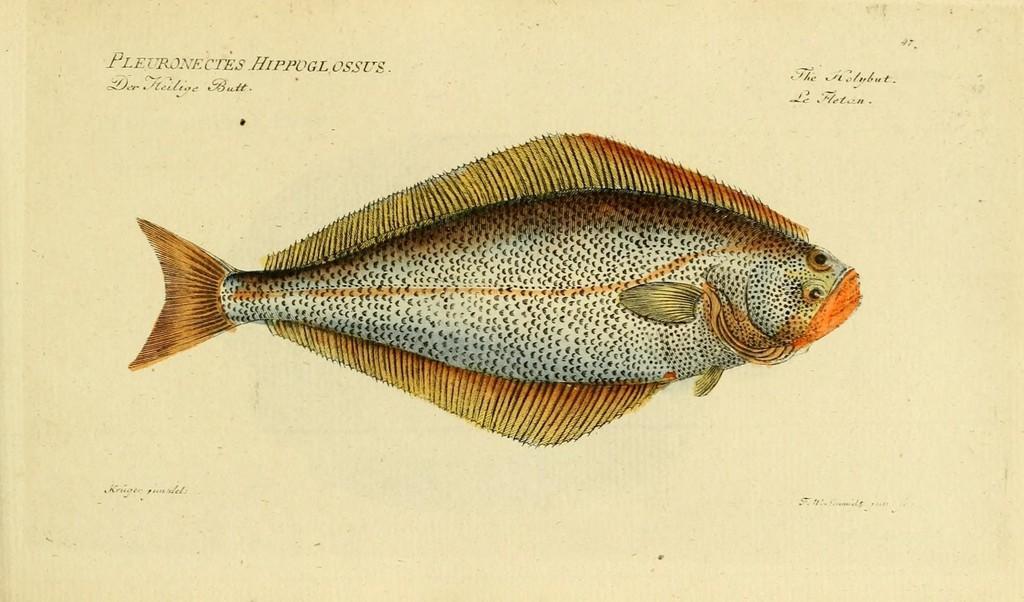How would you summarize this image in a sentence or two? In the center of the image a fish is present. At the top right and left corner text is there. At the bottom left and right corner text is present. 